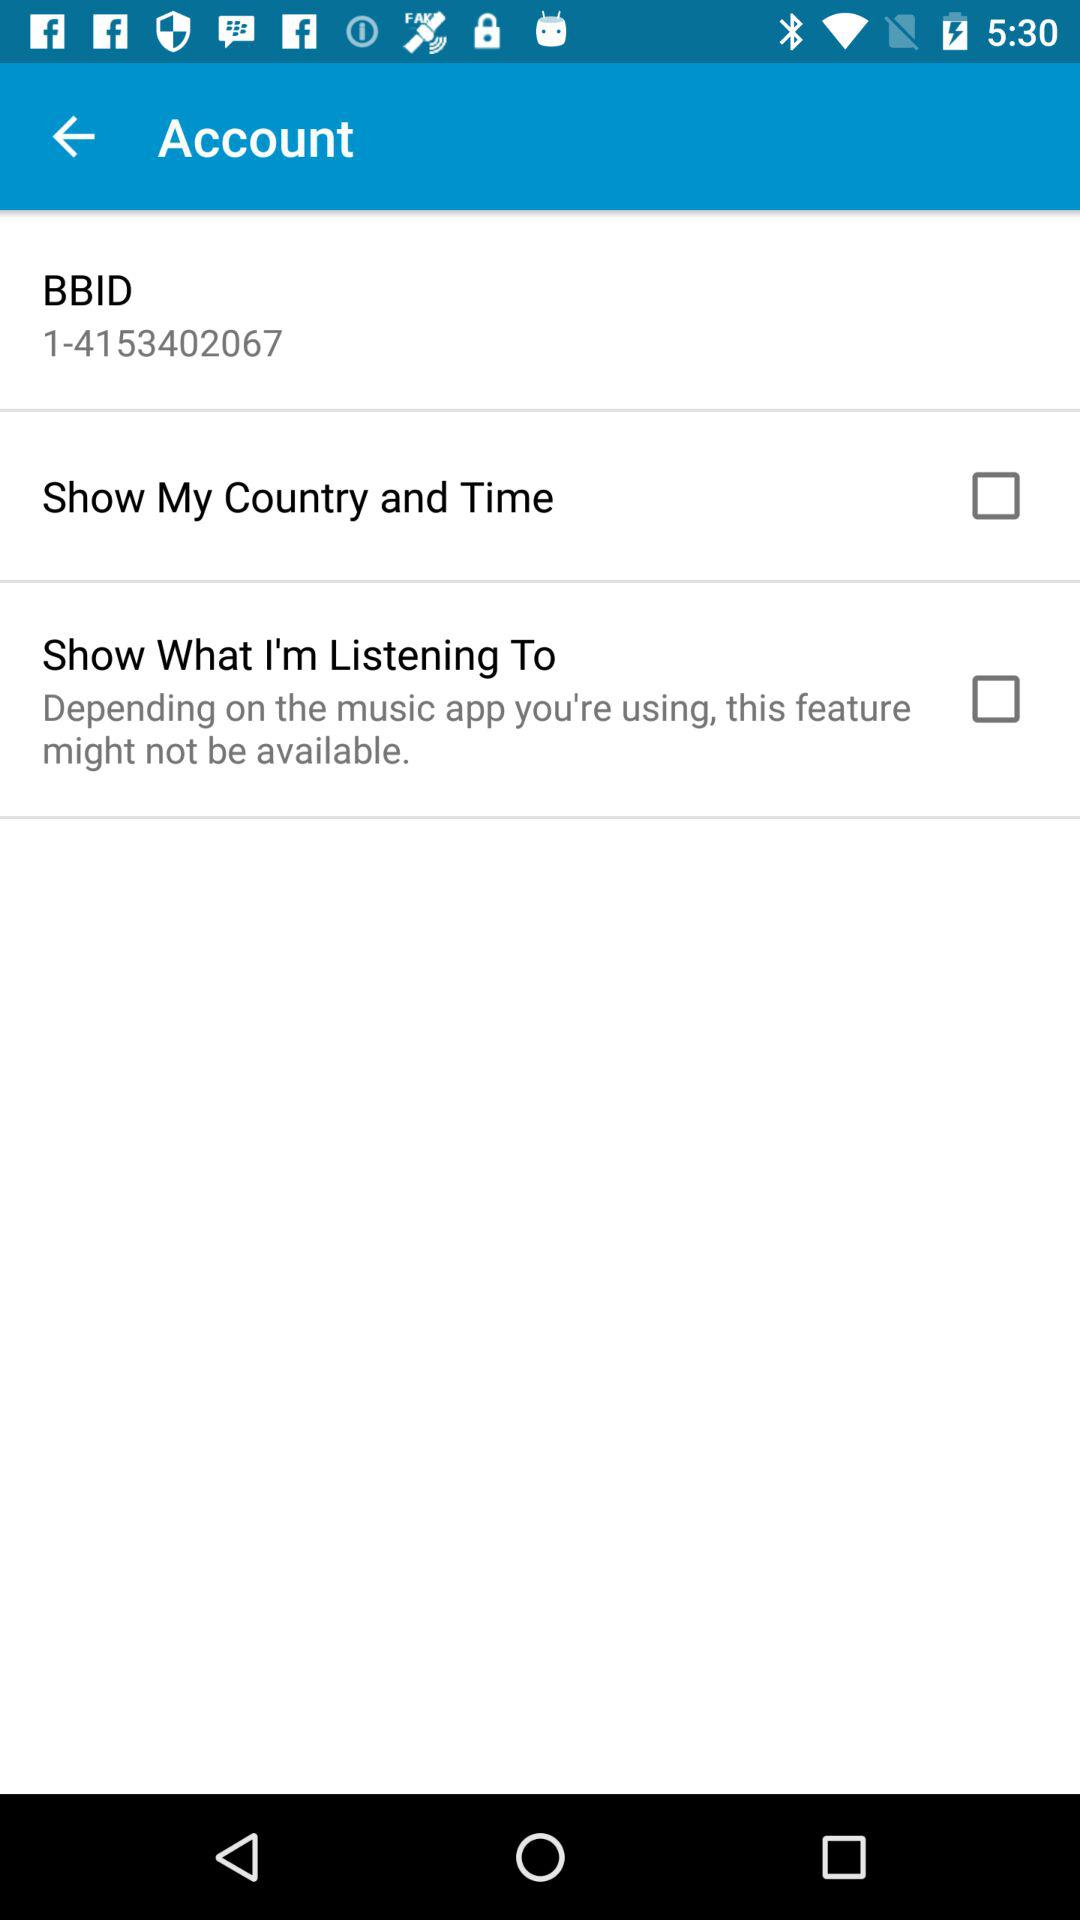What is the BBID number? The BBID number is 1-4153402067. 